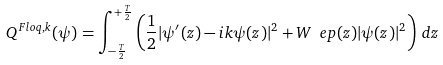<formula> <loc_0><loc_0><loc_500><loc_500>Q ^ { F l o q , k } ( \psi ) = \int _ { - \frac { T } { 2 } } ^ { + \frac { T } { 2 } } \left ( \frac { 1 } { 2 } | \psi ^ { \prime } ( z ) - i k \psi ( z ) | ^ { 2 } + W _ { \ } e p ( z ) | \psi ( z ) | ^ { 2 } \right ) \, d z</formula> 